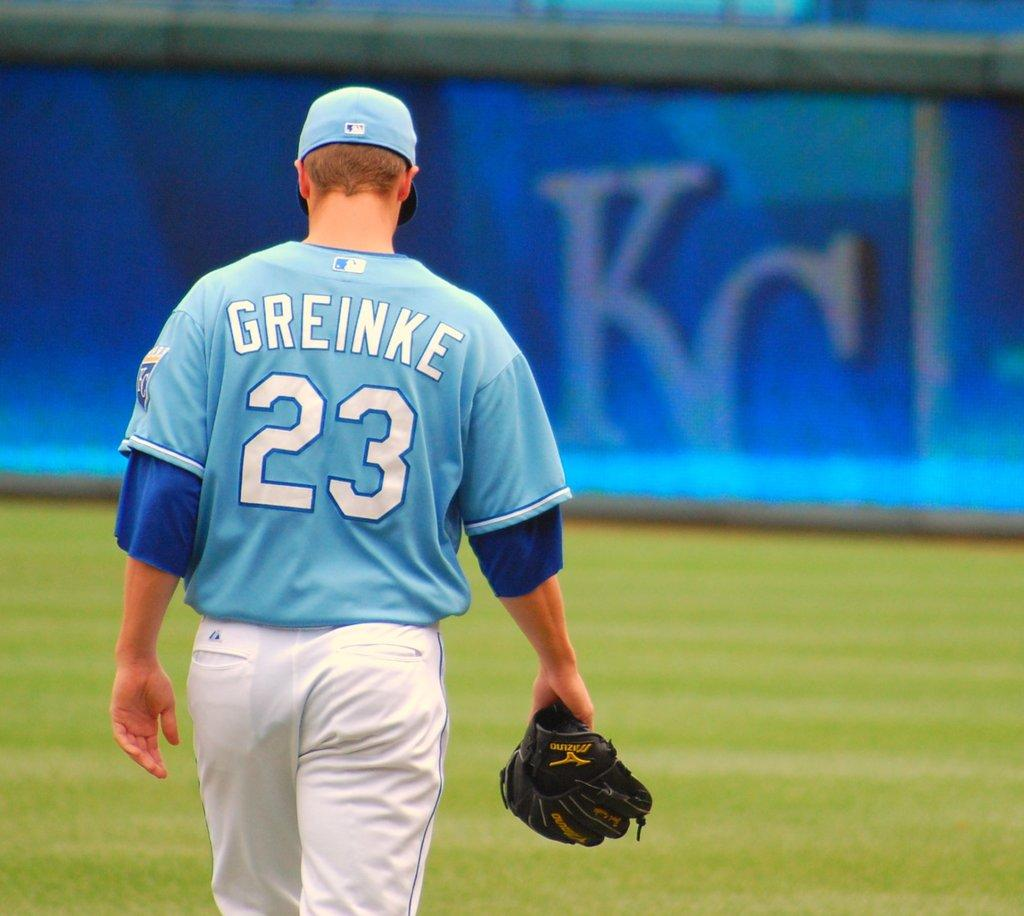<image>
Share a concise interpretation of the image provided. Number 23, Greinke is displayed on this player's uniform. 